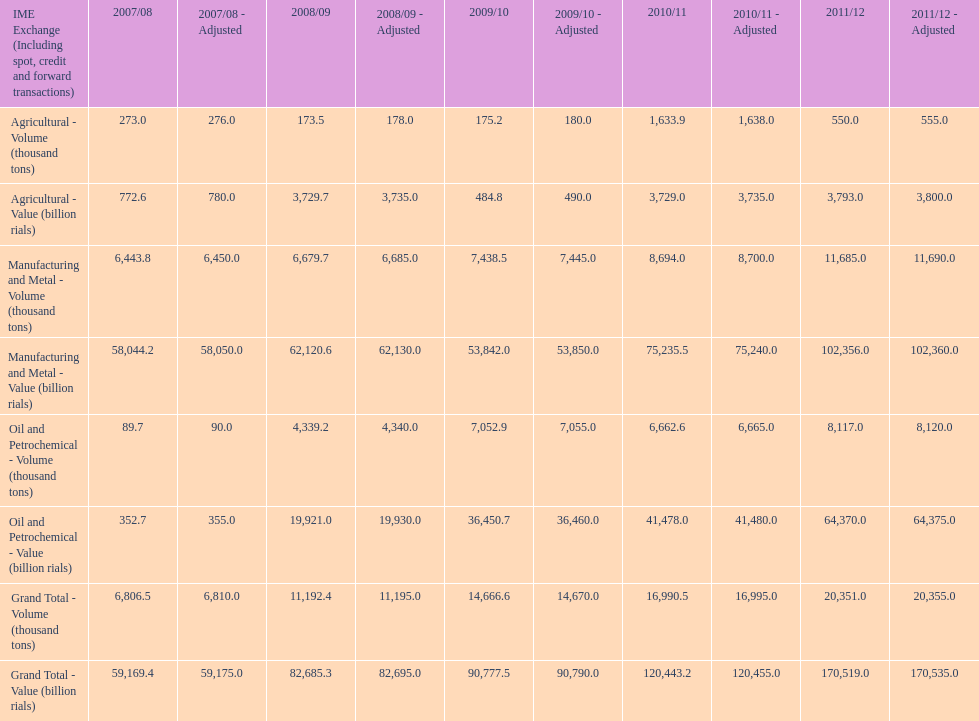In how many years was the value of agriculture, in billion rials, greater than 500 in iran? 4. 